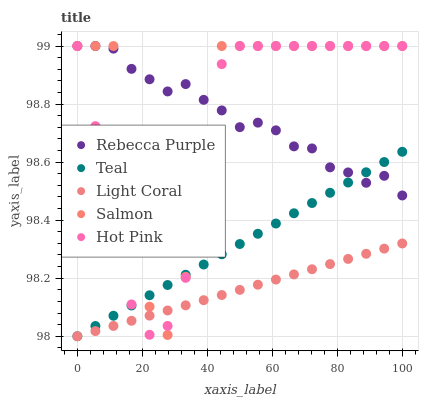Does Light Coral have the minimum area under the curve?
Answer yes or no. Yes. Does Salmon have the maximum area under the curve?
Answer yes or no. Yes. Does Hot Pink have the minimum area under the curve?
Answer yes or no. No. Does Hot Pink have the maximum area under the curve?
Answer yes or no. No. Is Teal the smoothest?
Answer yes or no. Yes. Is Salmon the roughest?
Answer yes or no. Yes. Is Hot Pink the smoothest?
Answer yes or no. No. Is Hot Pink the roughest?
Answer yes or no. No. Does Light Coral have the lowest value?
Answer yes or no. Yes. Does Hot Pink have the lowest value?
Answer yes or no. No. Does Rebecca Purple have the highest value?
Answer yes or no. Yes. Does Teal have the highest value?
Answer yes or no. No. Is Light Coral less than Rebecca Purple?
Answer yes or no. Yes. Is Rebecca Purple greater than Light Coral?
Answer yes or no. Yes. Does Teal intersect Hot Pink?
Answer yes or no. Yes. Is Teal less than Hot Pink?
Answer yes or no. No. Is Teal greater than Hot Pink?
Answer yes or no. No. Does Light Coral intersect Rebecca Purple?
Answer yes or no. No. 